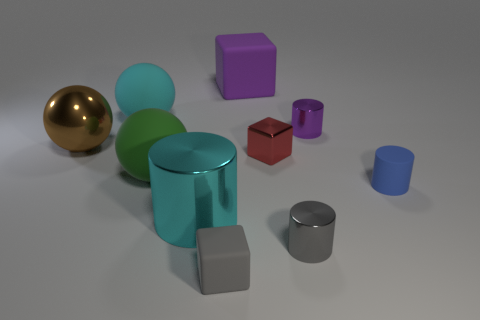What color is the other metal object that is the same shape as the big purple object?
Provide a succinct answer. Red. What is the purple block made of?
Provide a short and direct response. Rubber. What material is the cylinder that is the same color as the large rubber cube?
Your answer should be compact. Metal. Is the shape of the gray thing that is behind the gray matte object the same as  the small gray matte object?
Provide a short and direct response. No. What number of objects are big brown spheres or large blue shiny blocks?
Offer a very short reply. 1. Are the tiny block behind the gray rubber object and the gray block made of the same material?
Keep it short and to the point. No. What size is the blue rubber thing?
Offer a terse response. Small. The object that is the same color as the large matte block is what shape?
Your answer should be compact. Cylinder. What number of balls are big brown things or gray things?
Your answer should be compact. 1. Are there the same number of cyan matte balls that are in front of the brown thing and small shiny things that are to the left of the tiny shiny block?
Provide a short and direct response. Yes. 